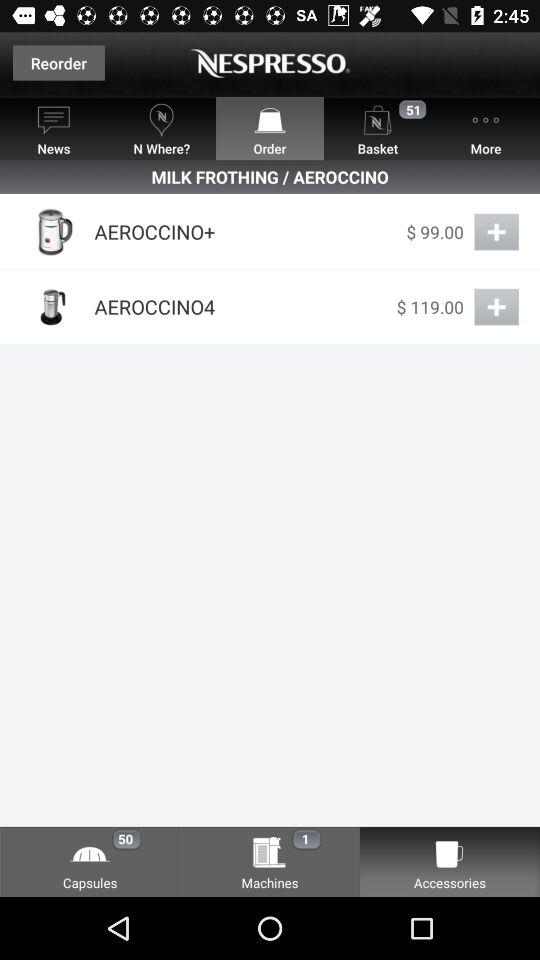Which tab is currently selected at the top bar? The selected tab is "Order". 